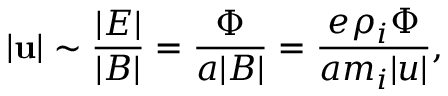<formula> <loc_0><loc_0><loc_500><loc_500>| u | \sim \frac { | E | } { | B | } = \frac { \Phi } { a | B | } = \frac { e \rho _ { i } \Phi } { a m _ { i } | u | } ,</formula> 